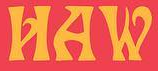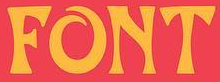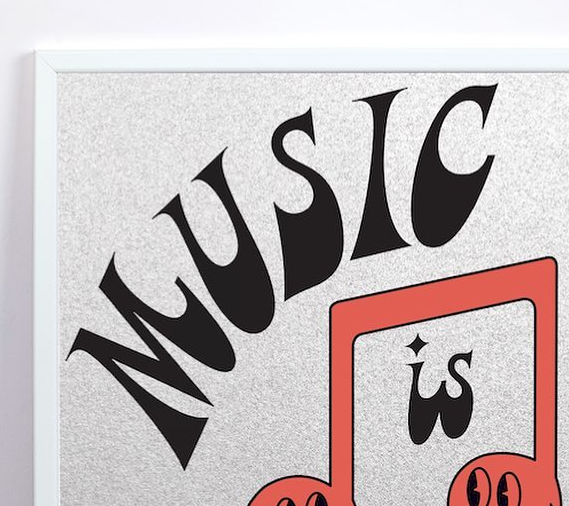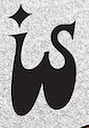What text is displayed in these images sequentially, separated by a semicolon? HAW; FONT; MUSIC; is 